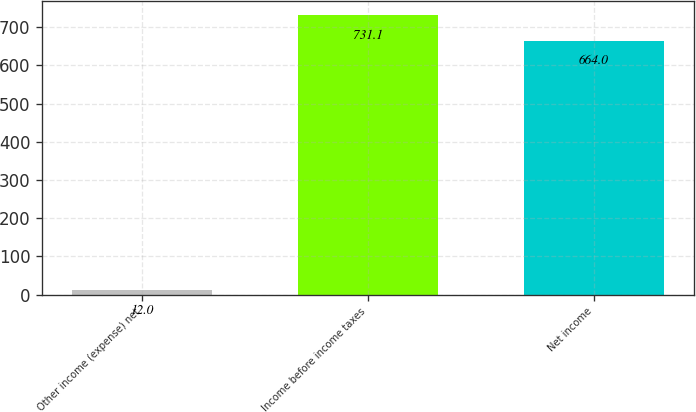Convert chart to OTSL. <chart><loc_0><loc_0><loc_500><loc_500><bar_chart><fcel>Other income (expense) net<fcel>Income before income taxes<fcel>Net income<nl><fcel>12<fcel>731.1<fcel>664<nl></chart> 